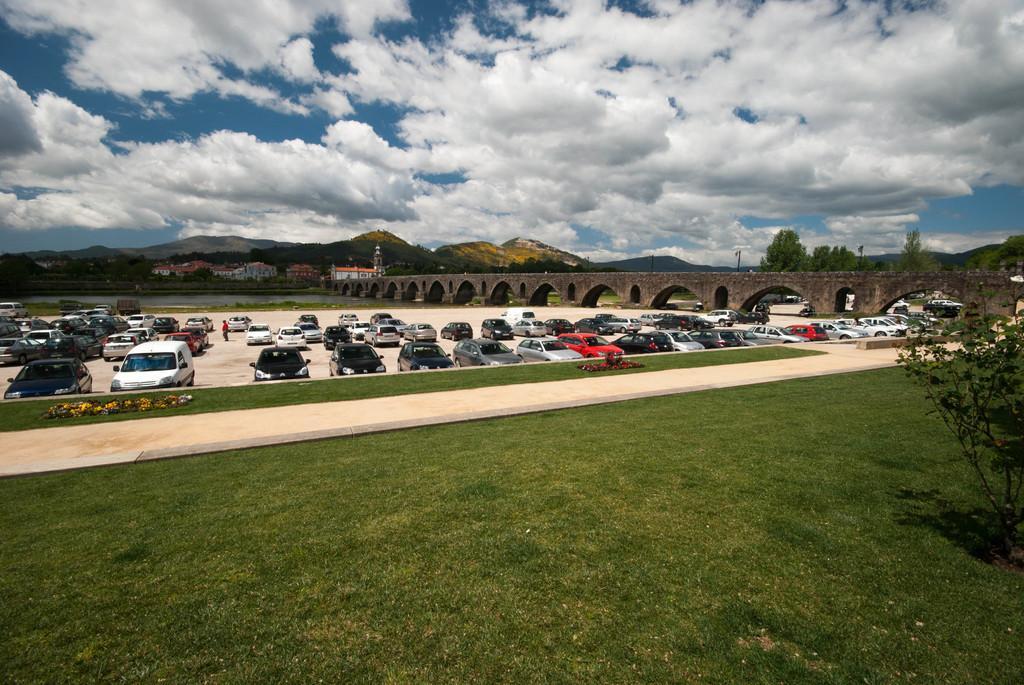Please provide a concise description of this image. In this picture there are few cars parked in parking place and there is a bridge in the right corner and there are few buildings and mountains in the background and the sky is cloudy. 